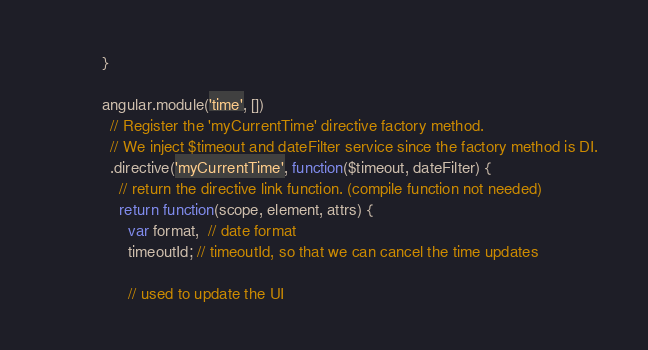<code> <loc_0><loc_0><loc_500><loc_500><_JavaScript_>            }

            angular.module('time', [])
              // Register the 'myCurrentTime' directive factory method.
              // We inject $timeout and dateFilter service since the factory method is DI.
              .directive('myCurrentTime', function($timeout, dateFilter) {
                // return the directive link function. (compile function not needed)
                return function(scope, element, attrs) {
                  var format,  // date format
                  timeoutId; // timeoutId, so that we can cancel the time updates

                  // used to update the UI</code> 